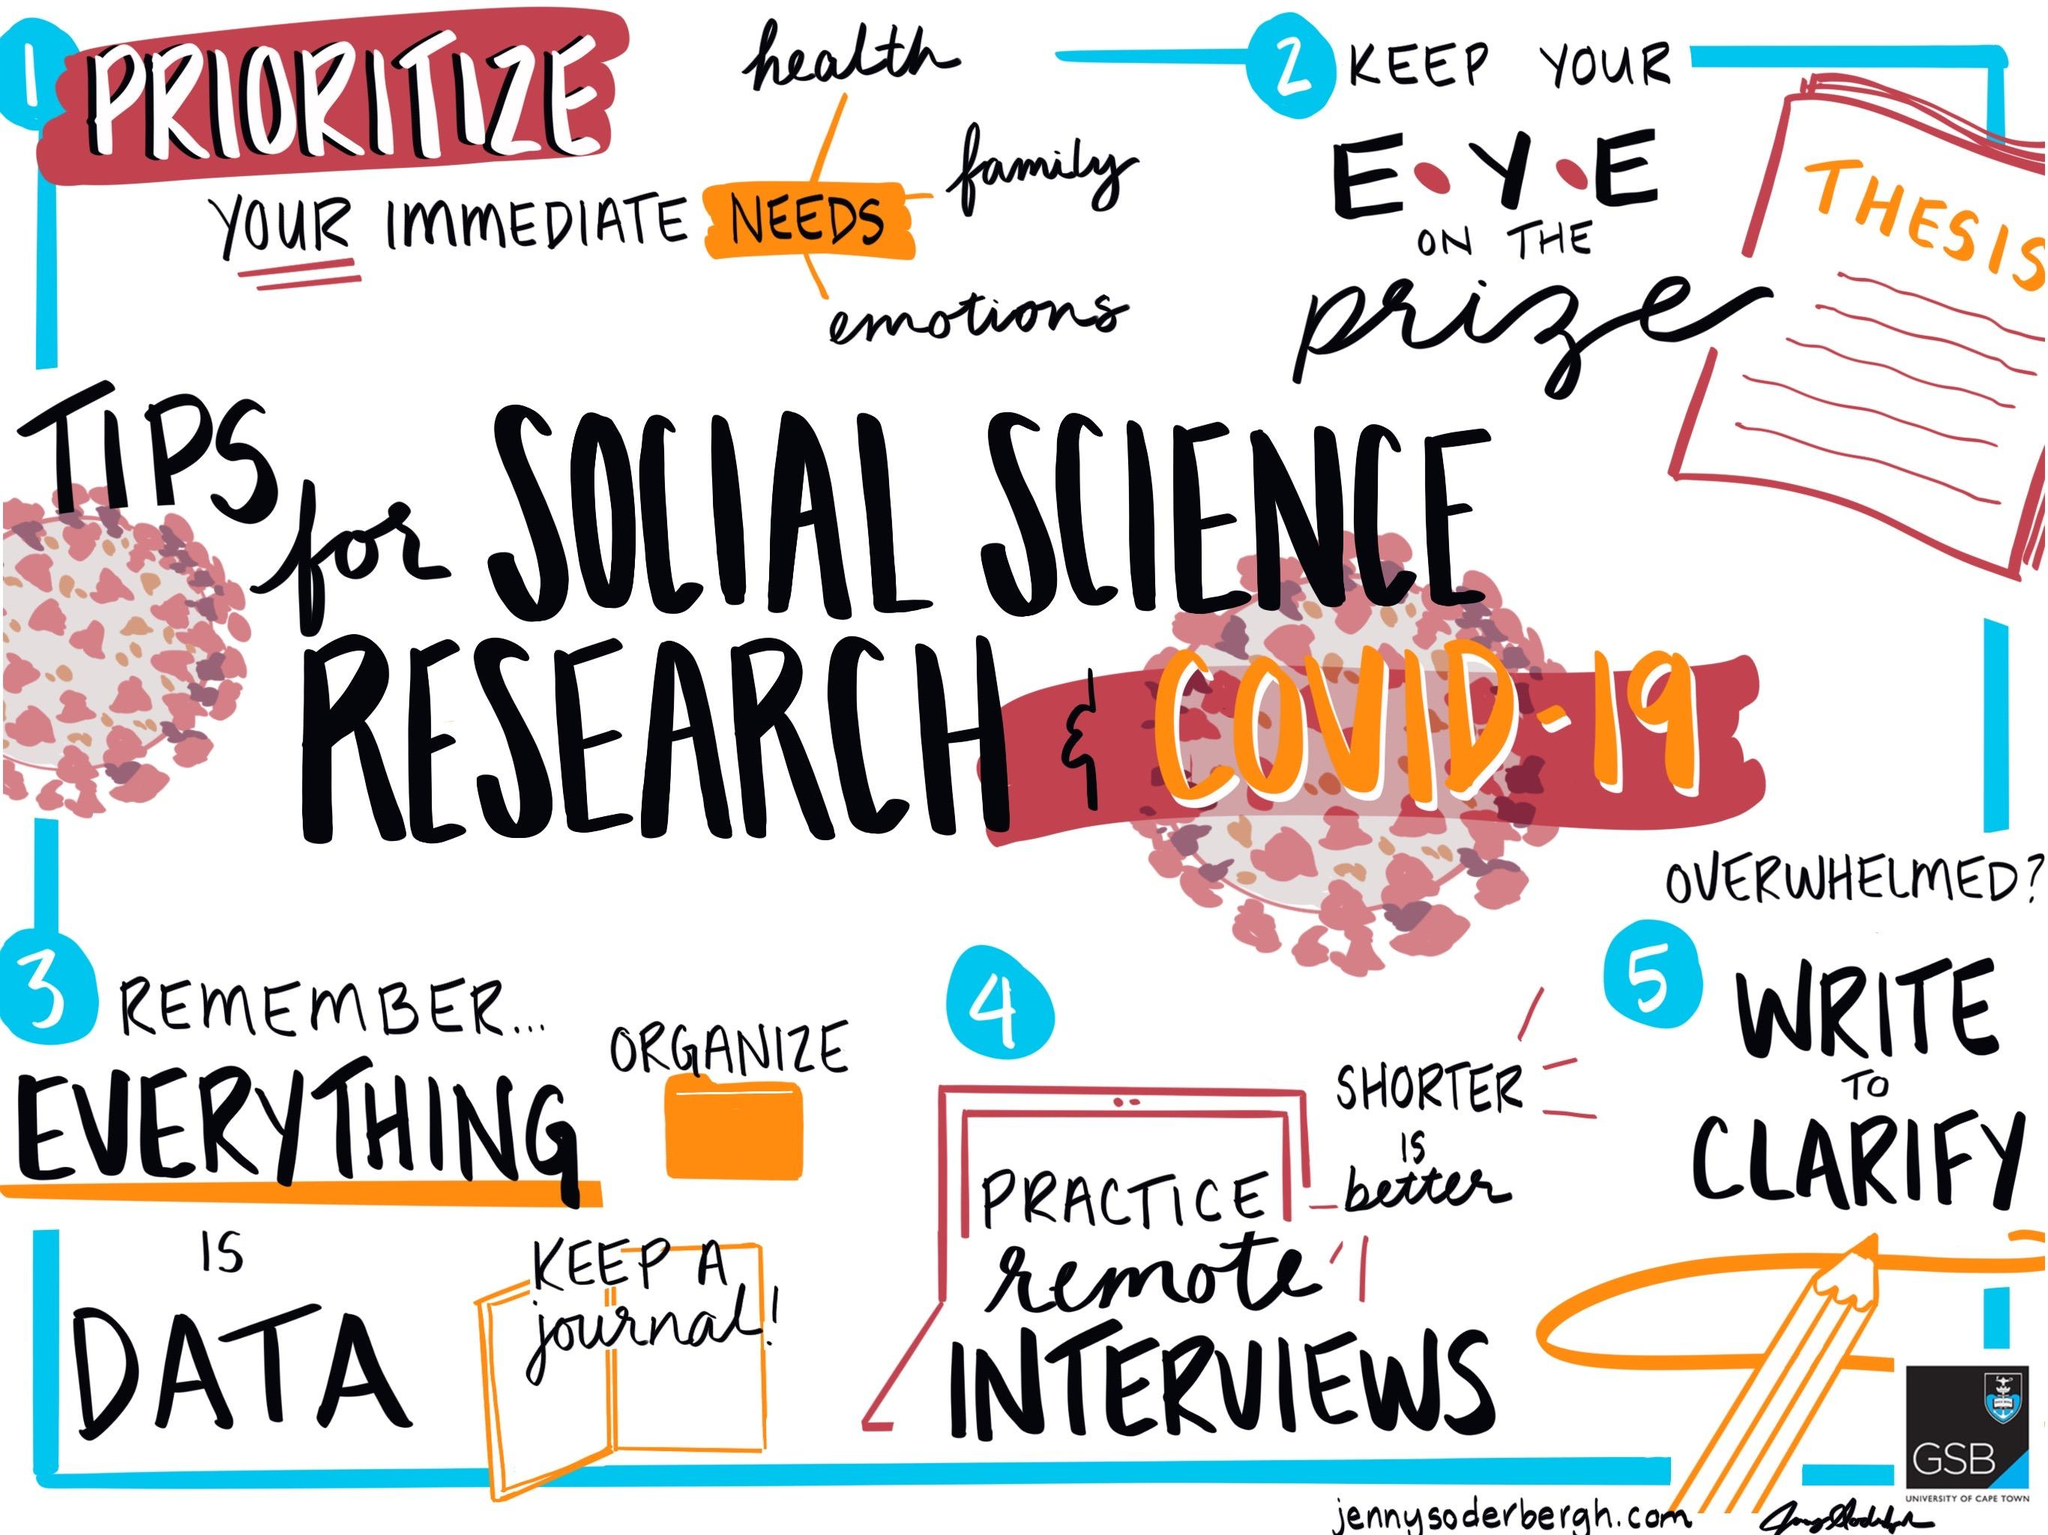Draw attention to some important aspects in this diagram. The fourth tip given in the image is to practice remote interviews. The fifth tip given in the image is "Be confident and assertive. 